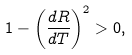<formula> <loc_0><loc_0><loc_500><loc_500>1 - \left ( \frac { d R } { d T } \right ) ^ { 2 } > 0 ,</formula> 